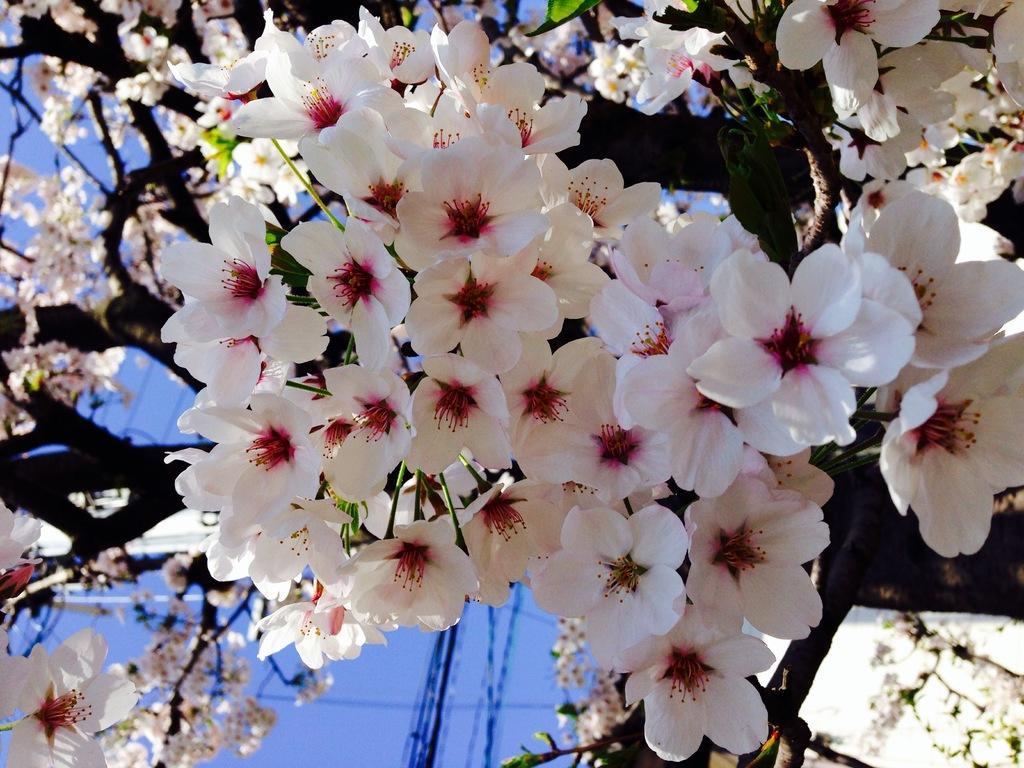In one or two sentences, can you explain what this image depicts? In the image we can see flowers, white and pink in color. Here we can see tree branches and the blue sky.  